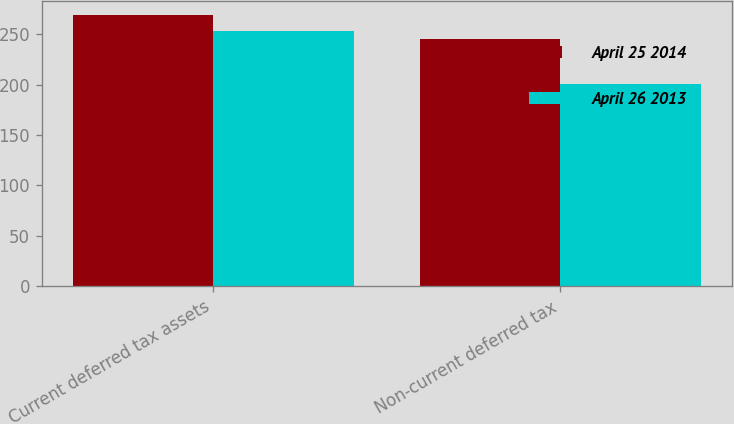<chart> <loc_0><loc_0><loc_500><loc_500><stacked_bar_chart><ecel><fcel>Current deferred tax assets<fcel>Non-current deferred tax<nl><fcel>April 25 2014<fcel>269.3<fcel>245<nl><fcel>April 26 2013<fcel>252.7<fcel>200.3<nl></chart> 